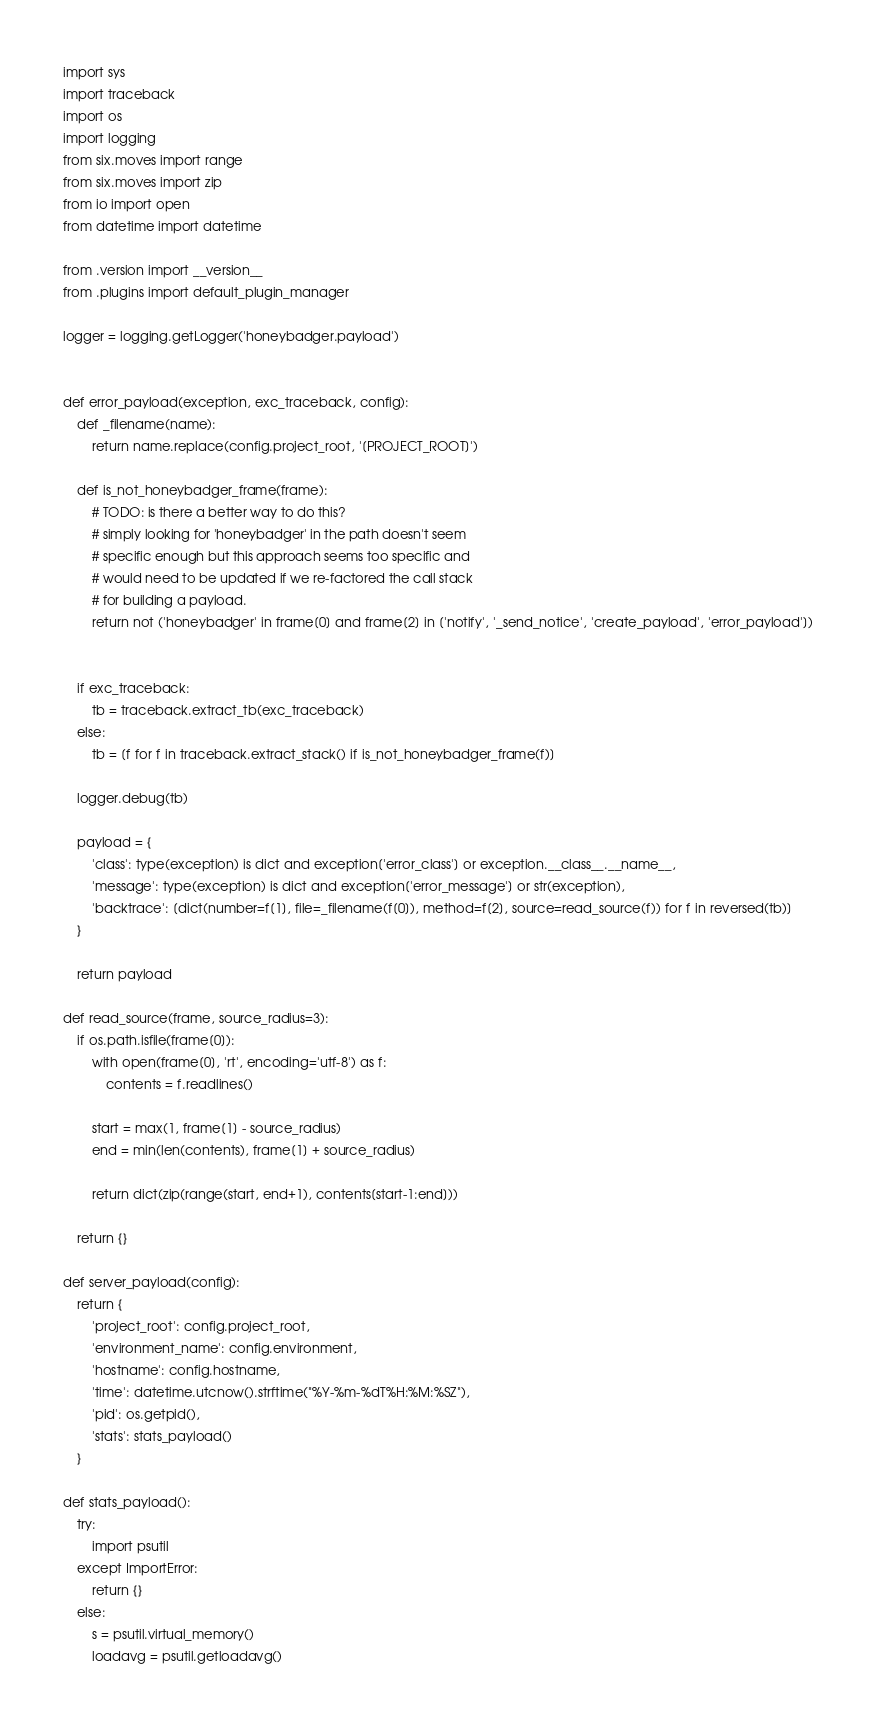<code> <loc_0><loc_0><loc_500><loc_500><_Python_>import sys
import traceback
import os
import logging
from six.moves import range
from six.moves import zip
from io import open
from datetime import datetime

from .version import __version__
from .plugins import default_plugin_manager

logger = logging.getLogger('honeybadger.payload')


def error_payload(exception, exc_traceback, config):
    def _filename(name):
        return name.replace(config.project_root, '[PROJECT_ROOT]')

    def is_not_honeybadger_frame(frame):
        # TODO: is there a better way to do this?
        # simply looking for 'honeybadger' in the path doesn't seem
        # specific enough but this approach seems too specific and
        # would need to be updated if we re-factored the call stack
        # for building a payload.
        return not ('honeybadger' in frame[0] and frame[2] in ['notify', '_send_notice', 'create_payload', 'error_payload'])


    if exc_traceback:
        tb = traceback.extract_tb(exc_traceback)
    else:
        tb = [f for f in traceback.extract_stack() if is_not_honeybadger_frame(f)]

    logger.debug(tb)

    payload = {
        'class': type(exception) is dict and exception['error_class'] or exception.__class__.__name__,
        'message': type(exception) is dict and exception['error_message'] or str(exception),
        'backtrace': [dict(number=f[1], file=_filename(f[0]), method=f[2], source=read_source(f)) for f in reversed(tb)]
    }

    return payload

def read_source(frame, source_radius=3):
    if os.path.isfile(frame[0]):
        with open(frame[0], 'rt', encoding='utf-8') as f:
            contents = f.readlines()

        start = max(1, frame[1] - source_radius)
        end = min(len(contents), frame[1] + source_radius)

        return dict(zip(range(start, end+1), contents[start-1:end]))

    return {}

def server_payload(config):
    return {
        'project_root': config.project_root,
        'environment_name': config.environment,
        'hostname': config.hostname,
        'time': datetime.utcnow().strftime("%Y-%m-%dT%H:%M:%SZ"),
        'pid': os.getpid(),
        'stats': stats_payload()
    }

def stats_payload():
    try:
        import psutil
    except ImportError:
        return {}
    else:
        s = psutil.virtual_memory()
        loadavg = psutil.getloadavg()
</code> 